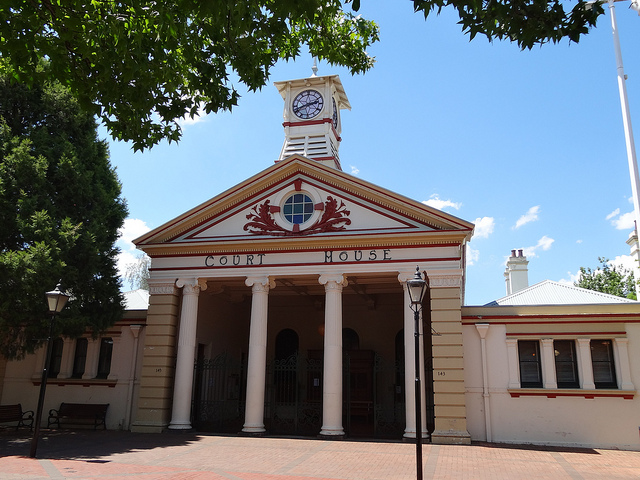Please extract the text content from this image. COURT HOUSE 